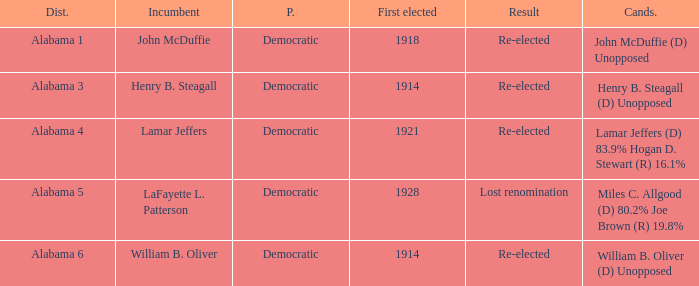How many in total were elected first in lost renomination? 1.0. 